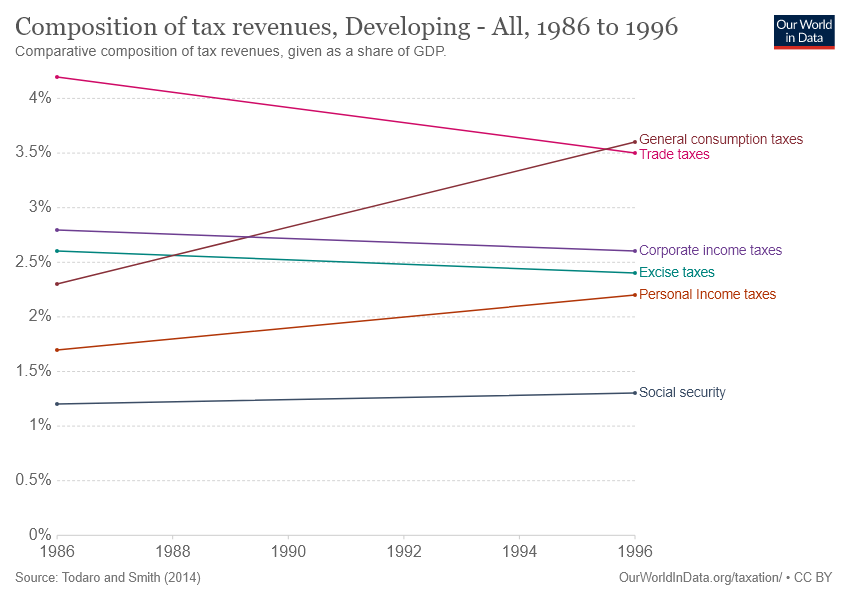Draw attention to some important aspects in this diagram. The record low for Composition of Trade taxes was in 1996. In the past, tax revenues have consistently made up more than 3% of the overall budget for at least one year. 